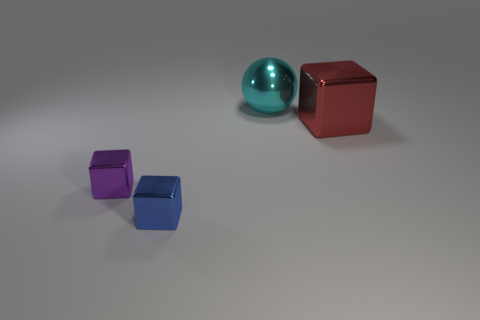There is a big object that is behind the red metallic cube; what is it made of?
Make the answer very short. Metal. Are there more cyan shiny spheres than large brown metallic blocks?
Keep it short and to the point. Yes. How many things are big things on the left side of the red thing or cubes?
Your answer should be compact. 4. There is a large metal thing behind the big red cube; how many metallic things are on the left side of it?
Give a very brief answer. 2. There is a object behind the large object to the right of the large thing on the left side of the red metallic object; how big is it?
Offer a very short reply. Large. There is a large metallic thing that is to the right of the large cyan object; is its color the same as the big sphere?
Keep it short and to the point. No. There is a red shiny thing that is the same shape as the purple object; what is its size?
Offer a very short reply. Large. How many objects are either large metallic objects on the right side of the large cyan ball or objects to the right of the blue metallic block?
Your response must be concise. 2. What shape is the large red thing on the right side of the tiny cube behind the small blue object?
Your answer should be compact. Cube. Is there anything else that has the same color as the sphere?
Your answer should be compact. No. 